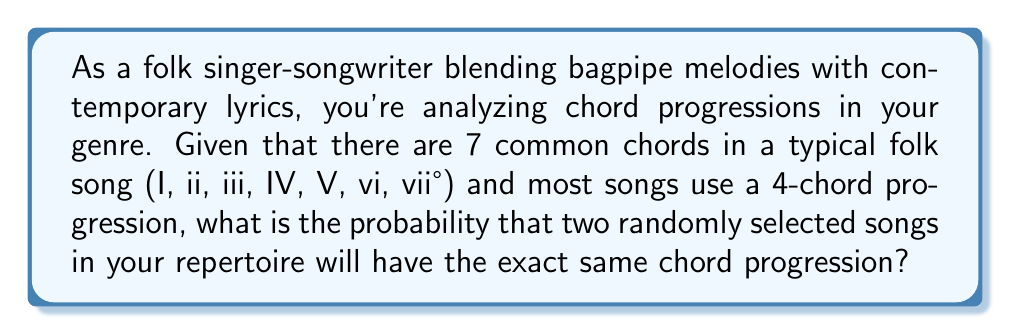Solve this math problem. Let's approach this step-by-step:

1) First, we need to calculate the total number of possible 4-chord progressions using 7 chords.

2) This is a problem of permutation with repetition, as chords can be repeated in a progression.

3) The formula for this is:
   $$n^r$$
   where n is the number of choices for each position, and r is the number of positions.

4) In this case:
   n = 7 (7 possible chords)
   r = 4 (4 chords in the progression)

5) So, the total number of possible chord progressions is:
   $$7^4 = 2401$$

6) Now, for two randomly selected songs to have the same chord progression, we need to calculate the probability of selecting the same progression twice.

7) The probability of selecting any specific progression is:
   $$\frac{1}{2401}$$

8) The probability of selecting that same progression again is also:
   $$\frac{1}{2401}$$

9) The probability of both events occurring is the product of their individual probabilities:
   $$\frac{1}{2401} \times \frac{1}{2401} = \frac{1}{5,764,801}$$

Therefore, the probability of two randomly selected songs having the exact same chord progression is 1 in 5,764,801.
Answer: $\frac{1}{5,764,801}$ 